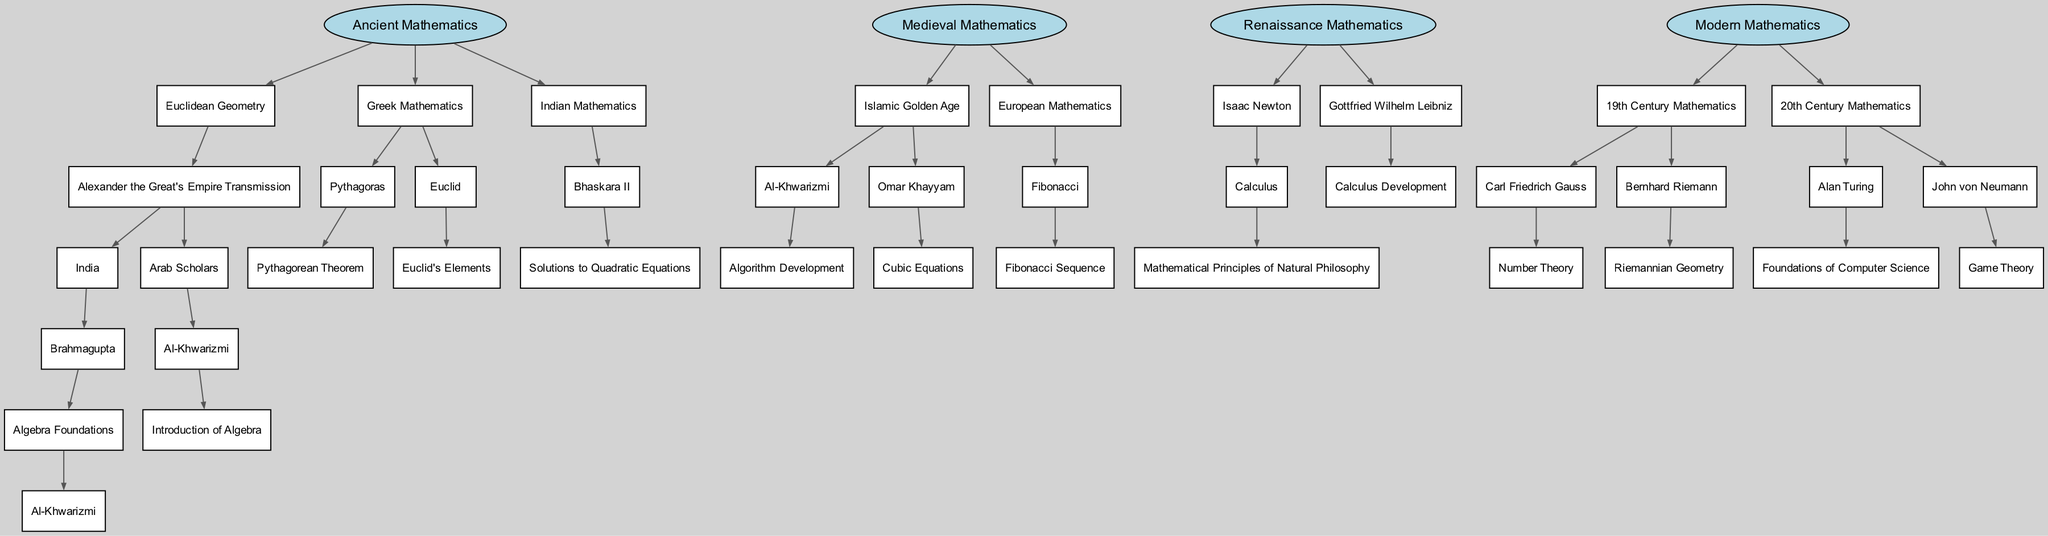What is the top node of the diagram? The top node is the root node titled "Ancient Mathematics," which represents the origin of the family tree regarding the development of mathematical theorems and concepts.
Answer: Ancient Mathematics How many children does "Euclidean Geometry" have? "Euclidean Geometry" has one child, which is "Alexander the Great's Empire Transmission." This can be seen by counting the immediate connections stemming from "Euclidean Geometry."
Answer: 1 Who introduced the "Fibonacci Sequence"? The "Fibonacci Sequence" was introduced by "Fibonacci," who is a child under the "European Mathematics" section of the diagram, indicating his contributions to the development of this concept.
Answer: Fibonacci What mathematical concept is associated with "Al-Khwarizmi" in the medieval era? In the medieval era, "Al-Khwarizmi" is associated with the concept of "Algorithm Development," which is a child node stemming from him, indicating key mathematical contributions during this time.
Answer: Algorithm Development Which mathematician is directly connected to "Calculus"? "Calculus" is directly connected to "Isaac Newton," as it is a concept attributed to him, represented as a child of his node in the "Renaissance Mathematics" section of the diagram.
Answer: Isaac Newton How many branches are there in "Modern Mathematics"? There are two main branches in "Modern Mathematics," namely "19th Century Mathematics" and "20th Century Mathematics," which can be observed as the two distinct child nodes under "Modern Mathematics."
Answer: 2 Which mathematician is recognized for "Number Theory"? "Number Theory" is recognized with "Carl Friedrich Gauss," as he is a child of the "19th Century Mathematics" node and specifies his significant work in this area.
Answer: Carl Friedrich Gauss What relationship exists between "Euclid's Elements" and the "Greek Mathematics" node? "Euclid's Elements" is a child node of "Euclid," who is under the "Greek Mathematics" section, showing that it is a seminal work pertaining to this field and time period.
Answer: Child relationship Identify the unique contribution of "John von Neumann." "John von Neumann" is uniquely credited with "Game Theory," as indicated by the direct line to this concept under "20th Century Mathematics," showcasing his influential work in the subject.
Answer: Game Theory What is the total number of unique mathematicians mentioned throughout the diagram? By systematically counting each unique mathematician’s node in the tree diagram, including branches across all historical periods, a total of ten distinctive mathematicians can be identified.
Answer: 10 